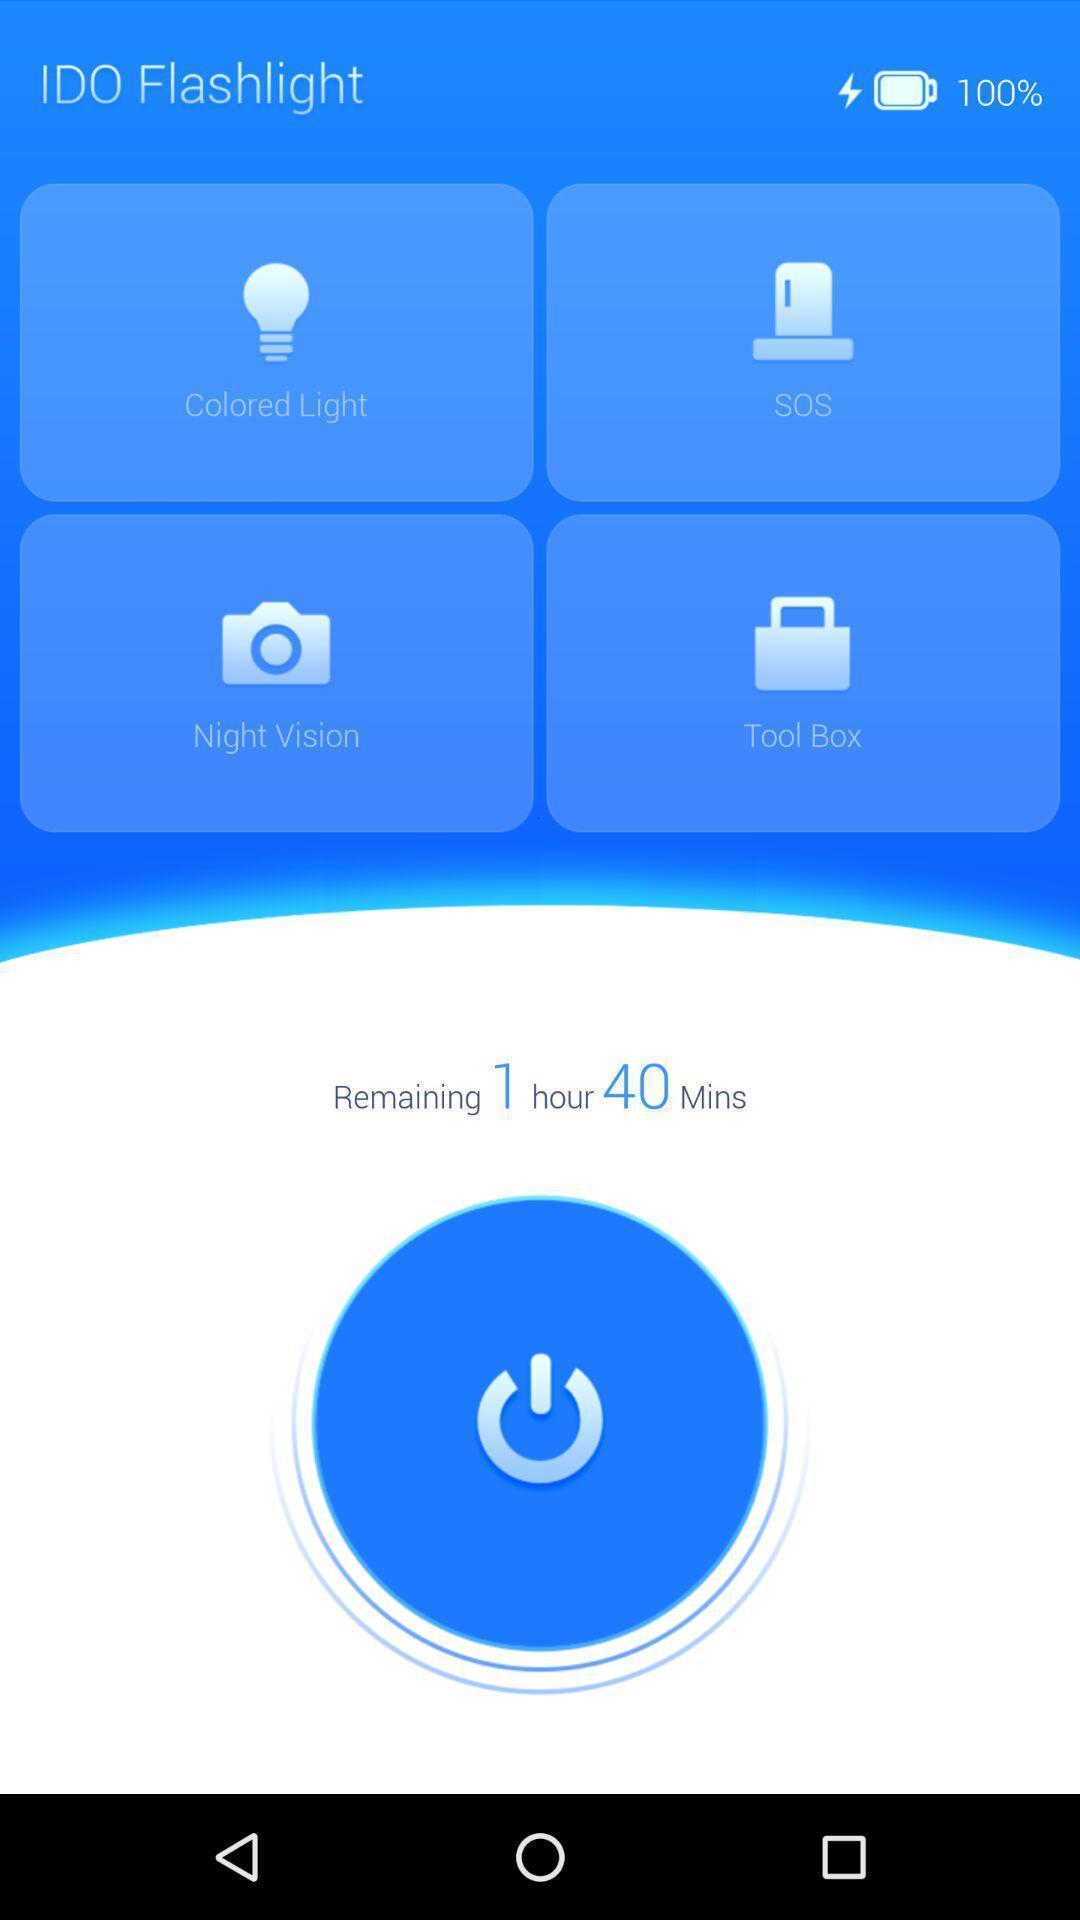Tell me what you see in this picture. Screen displaying several icons and a timer. 